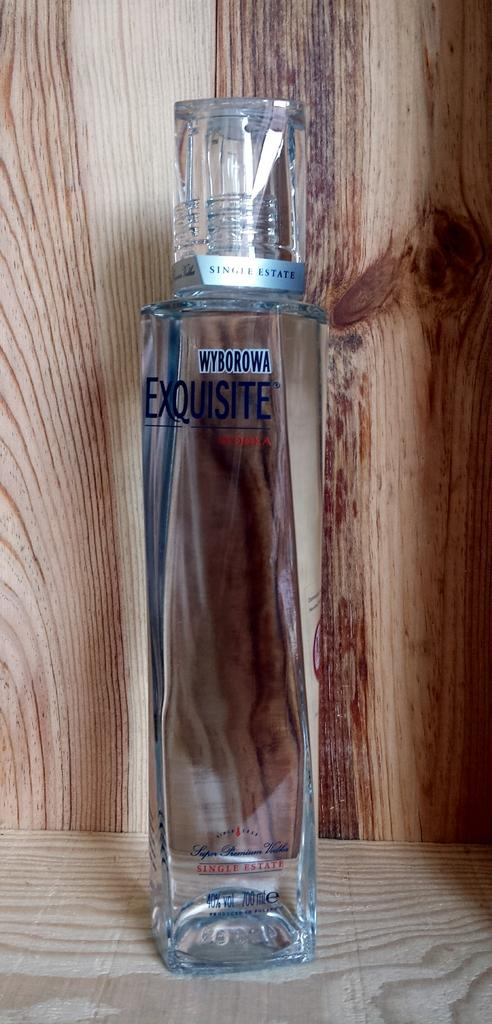<image>
Write a terse but informative summary of the picture. A glass bottle filled with Wyborowa Exquisite vodka. 